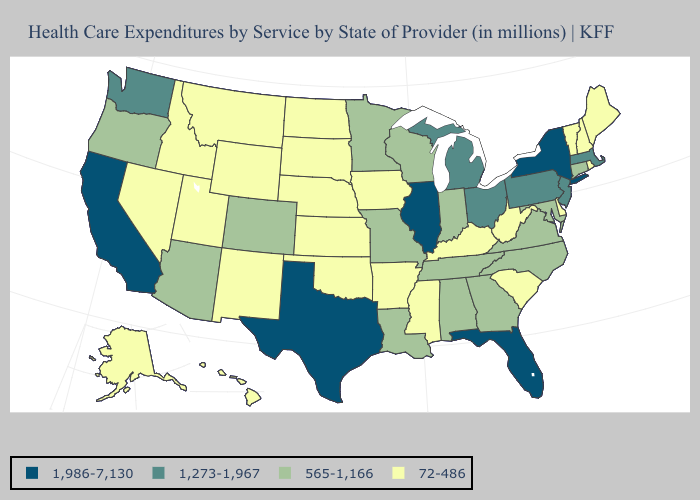What is the value of Maine?
Concise answer only. 72-486. Does New Hampshire have the same value as Michigan?
Give a very brief answer. No. Which states have the highest value in the USA?
Quick response, please. California, Florida, Illinois, New York, Texas. Name the states that have a value in the range 72-486?
Give a very brief answer. Alaska, Arkansas, Delaware, Hawaii, Idaho, Iowa, Kansas, Kentucky, Maine, Mississippi, Montana, Nebraska, Nevada, New Hampshire, New Mexico, North Dakota, Oklahoma, Rhode Island, South Carolina, South Dakota, Utah, Vermont, West Virginia, Wyoming. Which states have the lowest value in the Northeast?
Keep it brief. Maine, New Hampshire, Rhode Island, Vermont. Is the legend a continuous bar?
Keep it brief. No. Name the states that have a value in the range 1,986-7,130?
Answer briefly. California, Florida, Illinois, New York, Texas. Which states have the lowest value in the USA?
Write a very short answer. Alaska, Arkansas, Delaware, Hawaii, Idaho, Iowa, Kansas, Kentucky, Maine, Mississippi, Montana, Nebraska, Nevada, New Hampshire, New Mexico, North Dakota, Oklahoma, Rhode Island, South Carolina, South Dakota, Utah, Vermont, West Virginia, Wyoming. Which states have the highest value in the USA?
Write a very short answer. California, Florida, Illinois, New York, Texas. Does Colorado have the lowest value in the West?
Write a very short answer. No. What is the value of Tennessee?
Write a very short answer. 565-1,166. What is the lowest value in states that border Iowa?
Give a very brief answer. 72-486. Among the states that border Rhode Island , does Connecticut have the highest value?
Short answer required. No. What is the value of Maryland?
Short answer required. 565-1,166. Which states have the lowest value in the West?
Answer briefly. Alaska, Hawaii, Idaho, Montana, Nevada, New Mexico, Utah, Wyoming. 